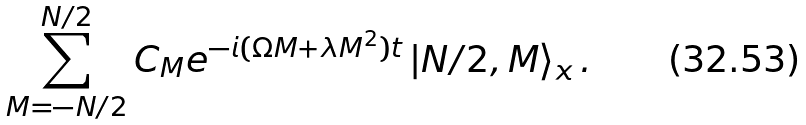<formula> <loc_0><loc_0><loc_500><loc_500>\sum _ { M = - N / 2 } ^ { N / 2 } C _ { M } e ^ { - i ( \Omega M + \lambda M ^ { 2 } ) t } \left | N / 2 , M \right \rangle _ { x } .</formula> 